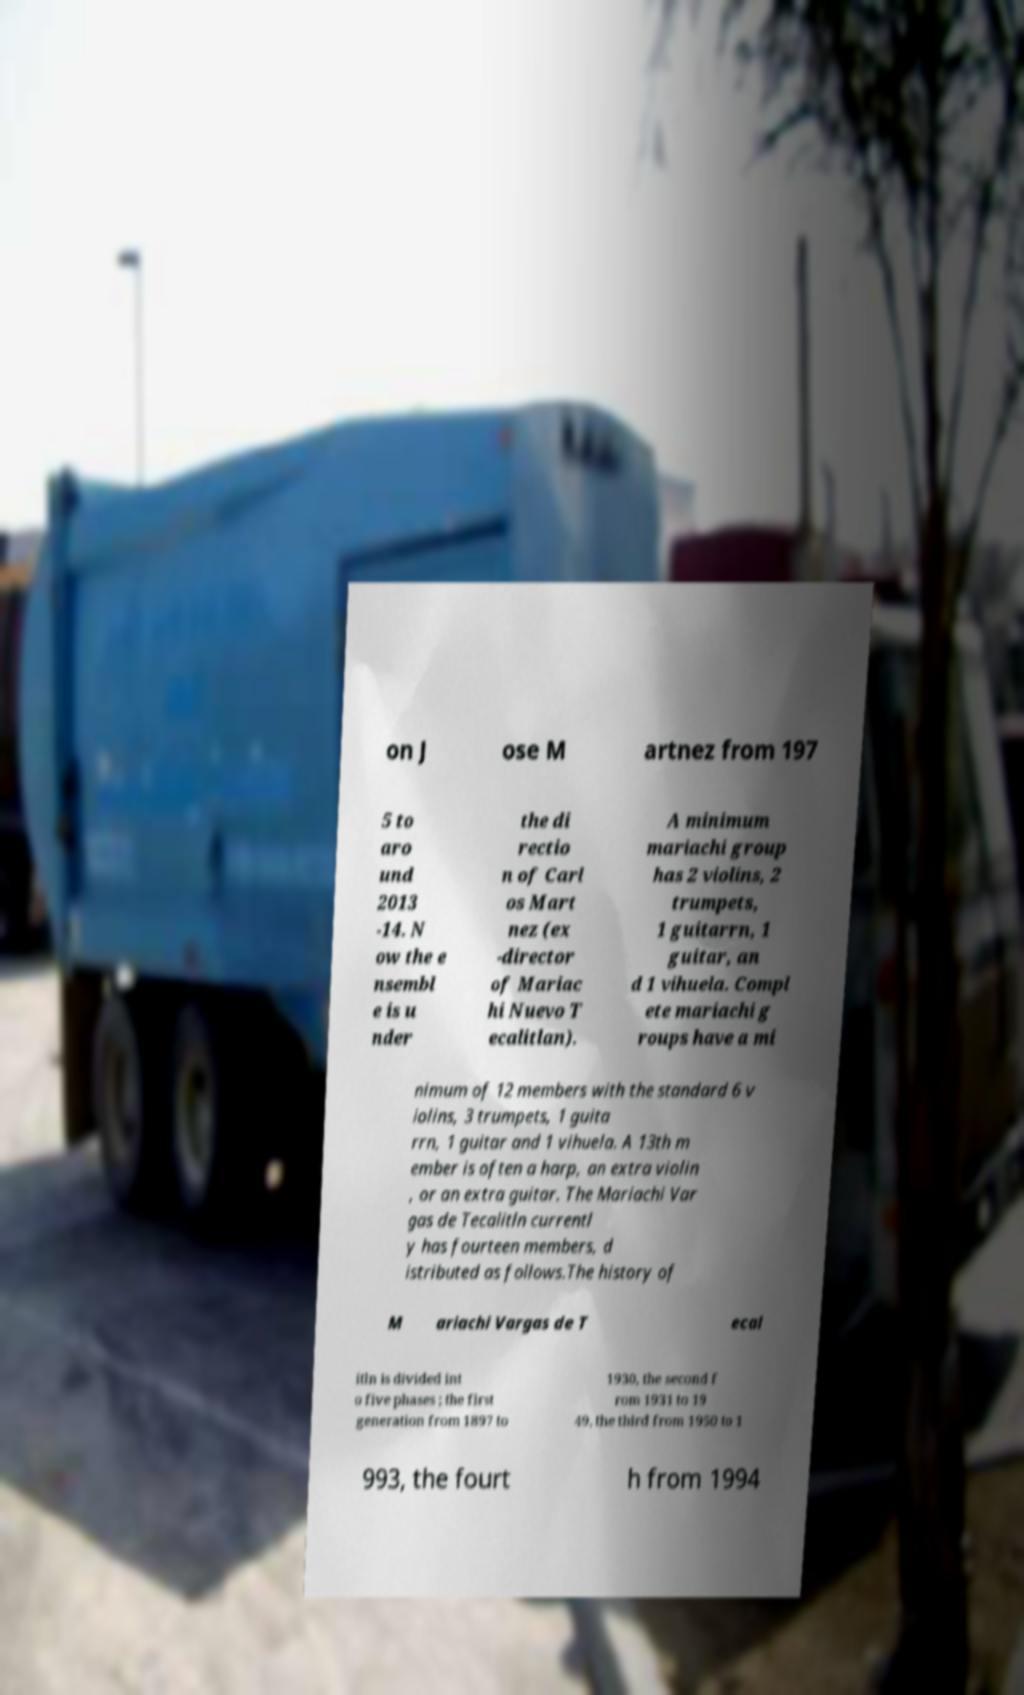Please identify and transcribe the text found in this image. on J ose M artnez from 197 5 to aro und 2013 -14. N ow the e nsembl e is u nder the di rectio n of Carl os Mart nez (ex -director of Mariac hi Nuevo T ecalitlan). A minimum mariachi group has 2 violins, 2 trumpets, 1 guitarrn, 1 guitar, an d 1 vihuela. Compl ete mariachi g roups have a mi nimum of 12 members with the standard 6 v iolins, 3 trumpets, 1 guita rrn, 1 guitar and 1 vihuela. A 13th m ember is often a harp, an extra violin , or an extra guitar. The Mariachi Var gas de Tecalitln currentl y has fourteen members, d istributed as follows.The history of M ariachi Vargas de T ecal itln is divided int o five phases ; the first generation from 1897 to 1930, the second f rom 1931 to 19 49, the third from 1950 to 1 993, the fourt h from 1994 